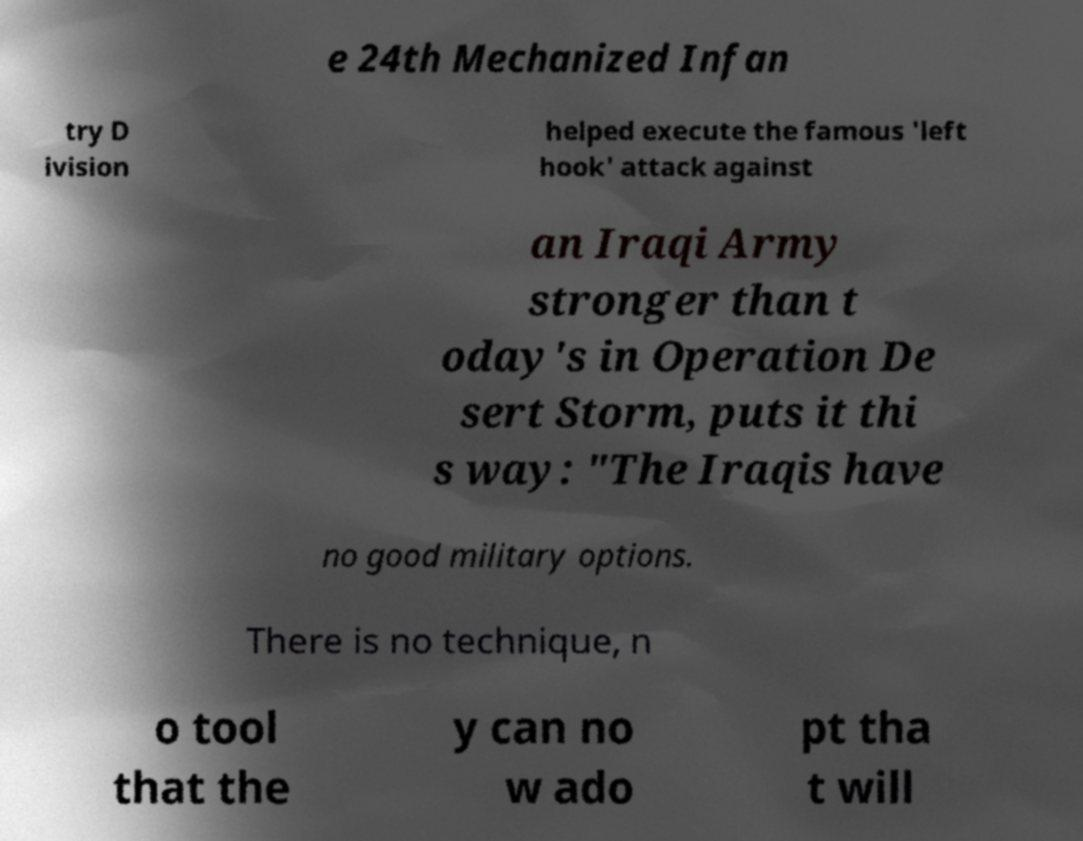Please read and relay the text visible in this image. What does it say? e 24th Mechanized Infan try D ivision helped execute the famous 'left hook' attack against an Iraqi Army stronger than t oday's in Operation De sert Storm, puts it thi s way: "The Iraqis have no good military options. There is no technique, n o tool that the y can no w ado pt tha t will 